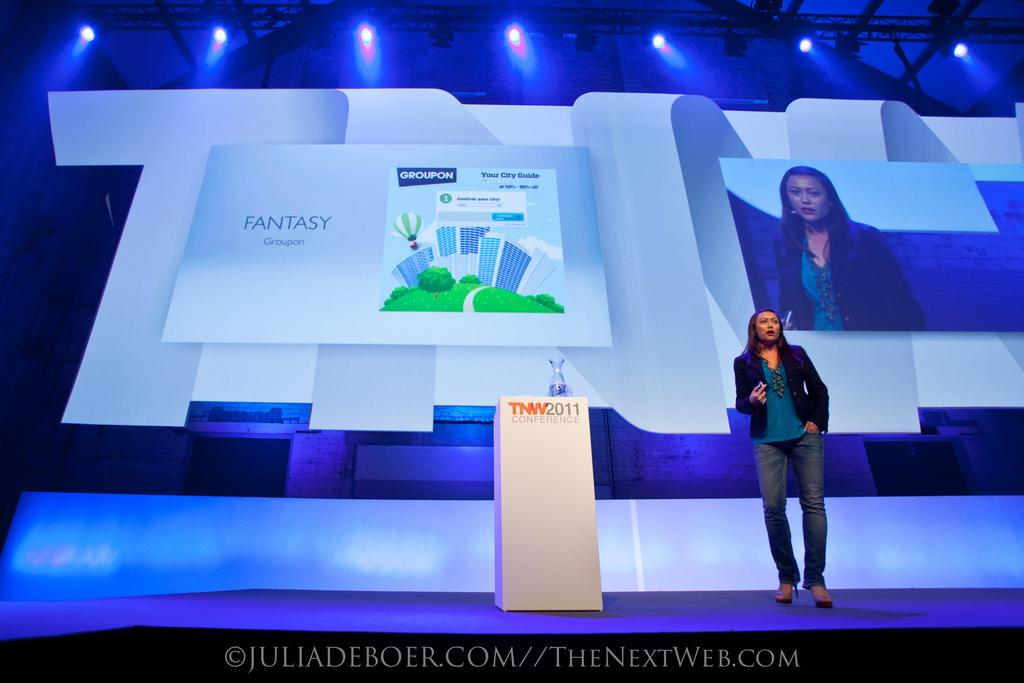What is the woman in the image doing? The woman is standing on a dais and speaking. What object is in the middle of the image? There is a podium in the middle of the image. What can be seen in the background of the image? There is a screen in the background of the image. What is located at the top of the image? There are lamps at the top of the image. What type of stick is the cow holding in the image? There is no cow or stick present in the image. 